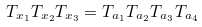Convert formula to latex. <formula><loc_0><loc_0><loc_500><loc_500>T _ { x _ { 1 } } T _ { x _ { 2 } } T _ { x _ { 3 } } = T _ { a _ { 1 } } T _ { a _ { 2 } } T _ { a _ { 3 } } T _ { a _ { 4 } }</formula> 